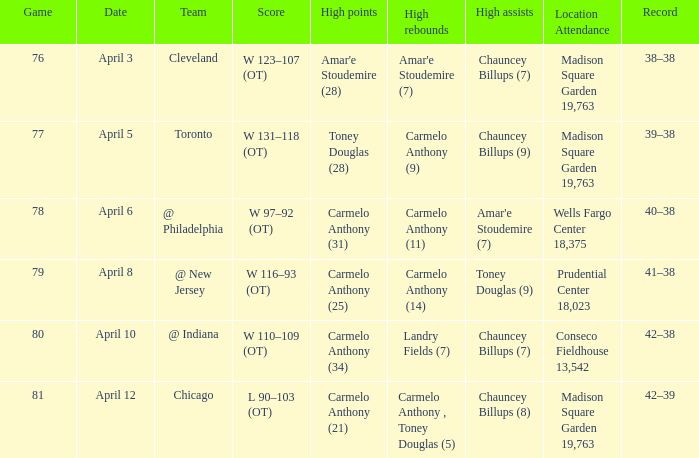With a 39-38 record and a 19,763-seat capacity, what were the most significant assists at madison square garden? Chauncey Billups (9). 